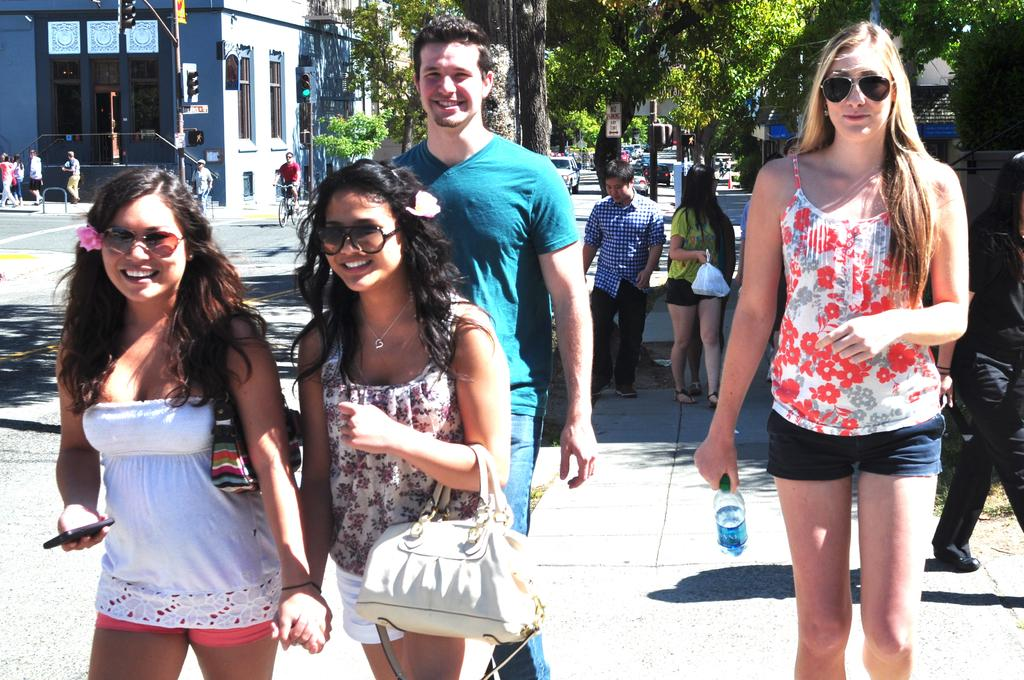What is happening in the image involving a group of people? There is a group of people in the image, and they are standing and holding water bottles. What can be seen in the background of the image? There are trees and a building visible in the image. Is there any transportation present in the image? Yes, a man is riding a bicycle in the image. What type of fireman is driving the things in the image? There is no fireman or driving of things present in the image. 